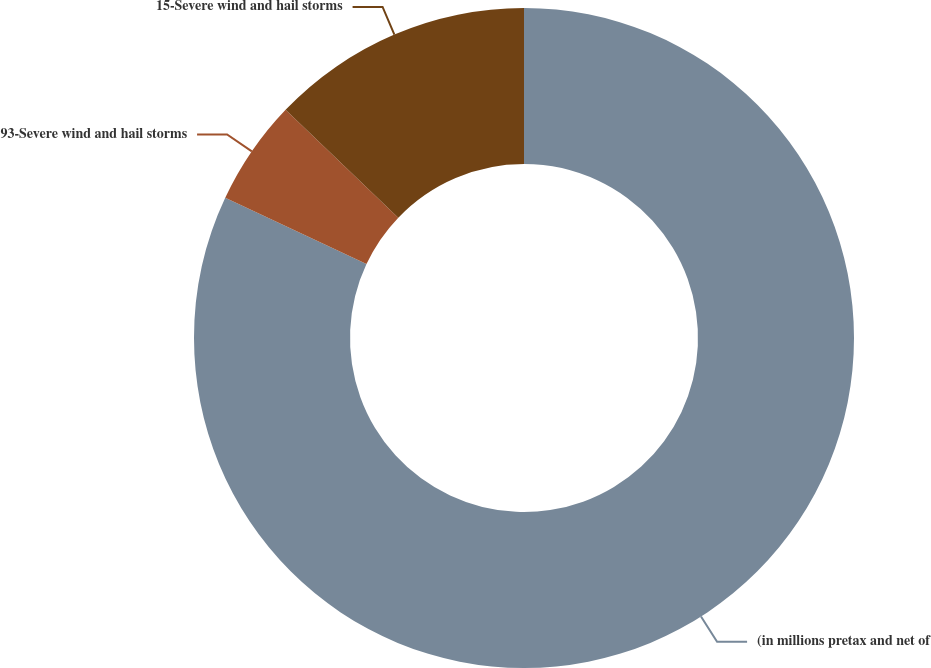<chart> <loc_0><loc_0><loc_500><loc_500><pie_chart><fcel>(in millions pretax and net of<fcel>93-Severe wind and hail storms<fcel>15-Severe wind and hail storms<nl><fcel>81.98%<fcel>5.17%<fcel>12.85%<nl></chart> 